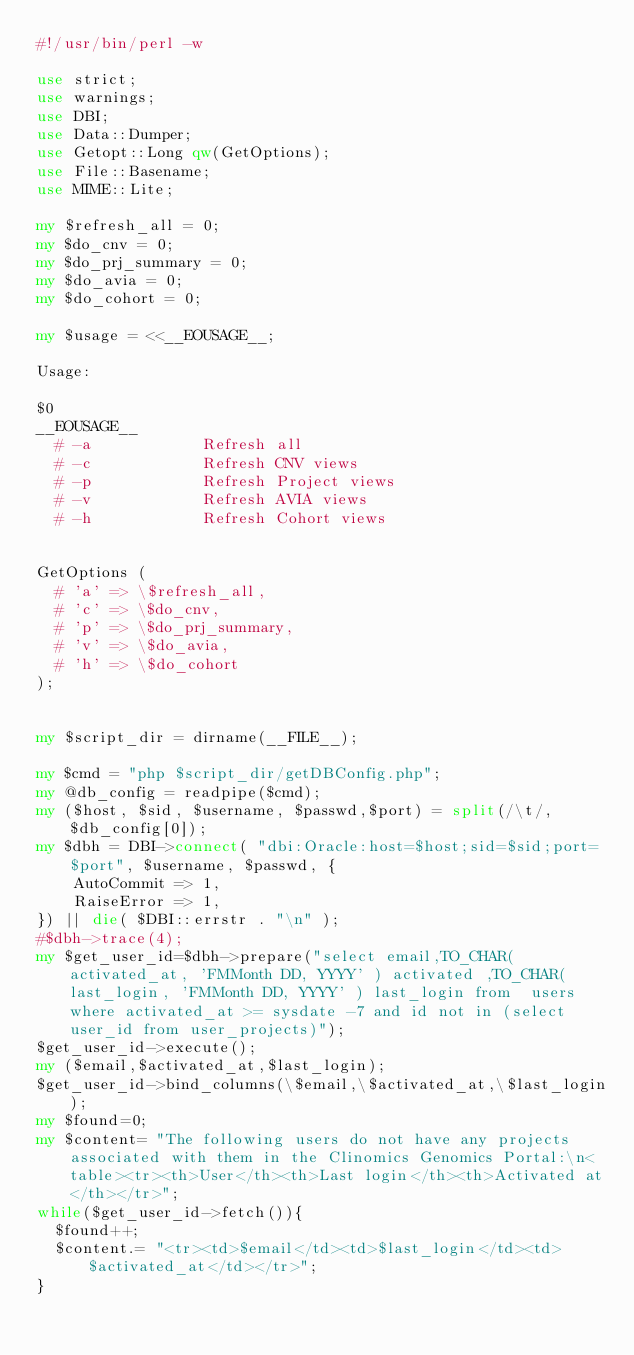<code> <loc_0><loc_0><loc_500><loc_500><_Perl_>#!/usr/bin/perl -w

use strict;
use warnings;
use DBI;
use Data::Dumper;
use Getopt::Long qw(GetOptions);
use File::Basename;
use MIME::Lite; 

my $refresh_all = 0;
my $do_cnv = 0;
my $do_prj_summary = 0;
my $do_avia = 0;
my $do_cohort = 0;

my $usage = <<__EOUSAGE__;

Usage:

$0   
__EOUSAGE__
  # -a            Refresh all
  # -c            Refresh CNV views
  # -p            Refresh Project views
  # -v            Refresh AVIA views
  # -h            Refresh Cohort views


GetOptions (
  # 'a' => \$refresh_all,
  # 'c' => \$do_cnv,
  # 'p' => \$do_prj_summary,
  # 'v' => \$do_avia,
  # 'h' => \$do_cohort
);


my $script_dir = dirname(__FILE__);

my $cmd = "php $script_dir/getDBConfig.php";
my @db_config = readpipe($cmd);
my ($host, $sid, $username, $passwd,$port) = split(/\t/, $db_config[0]);
my $dbh = DBI->connect( "dbi:Oracle:host=$host;sid=$sid;port=$port", $username, $passwd, {
    AutoCommit => 1,
    RaiseError => 1,    
}) || die( $DBI::errstr . "\n" );
#$dbh->trace(4);
my $get_user_id=$dbh->prepare("select email,TO_CHAR( activated_at, 'FMMonth DD, YYYY' ) activated ,TO_CHAR( last_login, 'FMMonth DD, YYYY' ) last_login from  users where activated_at >= sysdate -7 and id not in (select user_id from user_projects)");
$get_user_id->execute();
my ($email,$activated_at,$last_login);
$get_user_id->bind_columns(\$email,\$activated_at,\$last_login);
my $found=0;
my $content= "The following users do not have any projects associated with them in the Clinomics Genomics Portal:\n<table><tr><th>User</th><th>Last login</th><th>Activated at</th></tr>";
while($get_user_id->fetch()){
	$found++;
	$content.= "<tr><td>$email</td><td>$last_login</td><td>$activated_at</td></tr>";
}</code> 